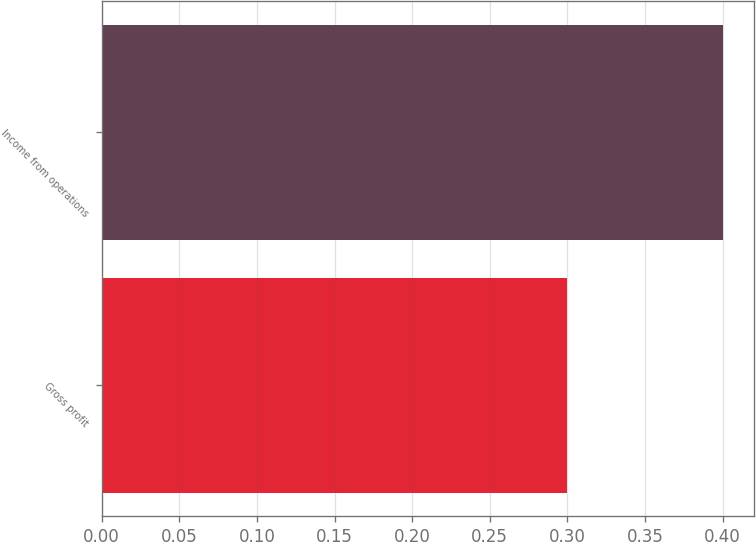Convert chart. <chart><loc_0><loc_0><loc_500><loc_500><bar_chart><fcel>Gross profit<fcel>Income from operations<nl><fcel>0.3<fcel>0.4<nl></chart> 